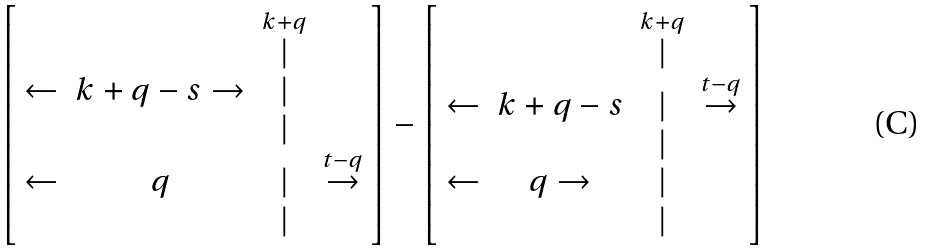<formula> <loc_0><loc_0><loc_500><loc_500>\left [ \begin{array} { c c c c } & & \overset { k + q } { | } & \\ \leftarrow & { k + q - s \rightarrow } & | & \\ & & | & \\ \leftarrow & q & | & \overset { t - q } { \rightarrow } \\ & & | & \end{array} \right ] - \left [ \begin{array} { c c c c } & & \overset { k + q } { | } & \\ \leftarrow & { k + q - s } & | & \overset { t - q } { \rightarrow } \\ & & | & \\ \leftarrow & q \rightarrow & | & \\ & & | & \end{array} \right ]</formula> 